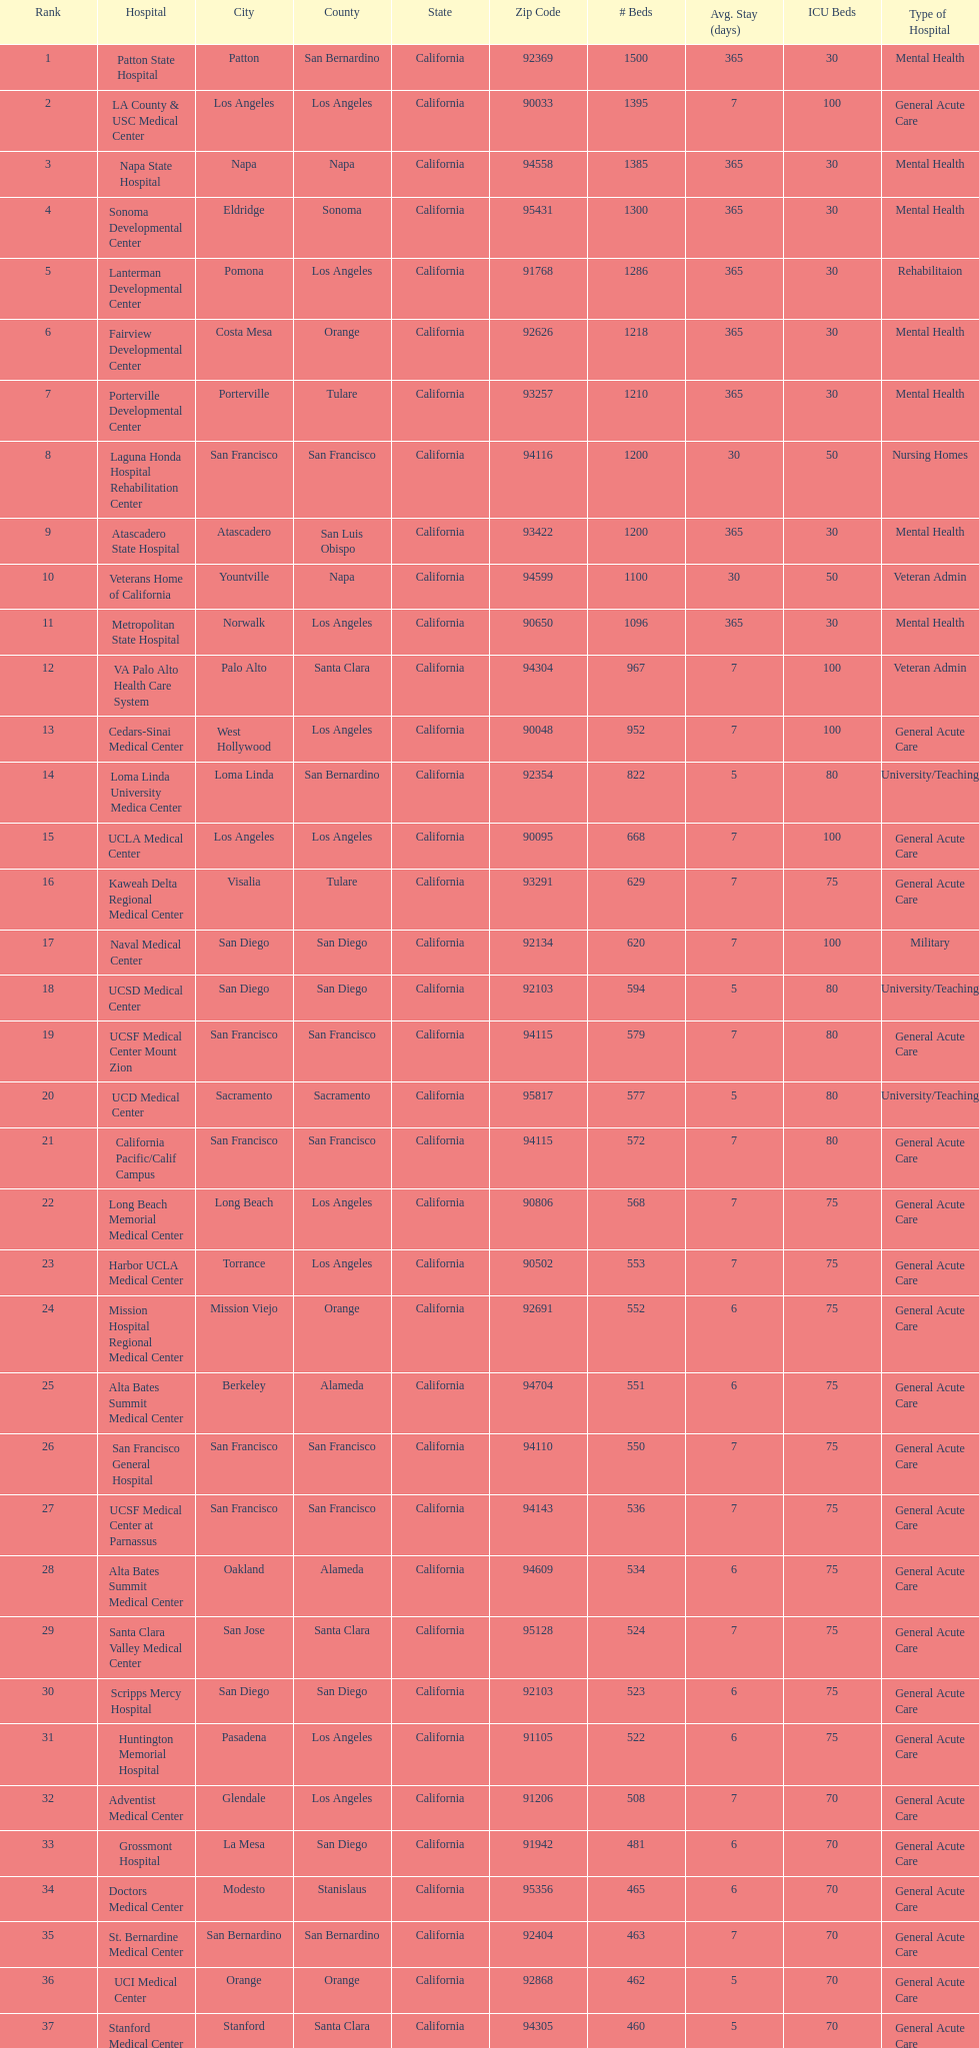What hospital in los angeles county providing hospital beds specifically for rehabilitation is ranked at least among the top 10 hospitals? Lanterman Developmental Center. 